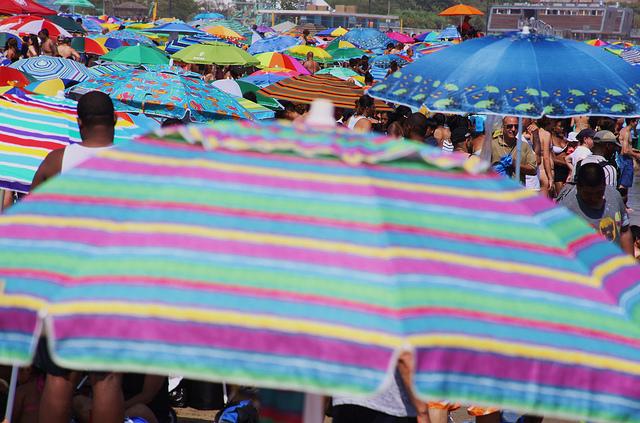Are there a lot of umbrellas?
Write a very short answer. Yes. What pattern is the front umbrella?
Keep it brief. Striped. Are there more people than umbrellas?
Answer briefly. Yes. 